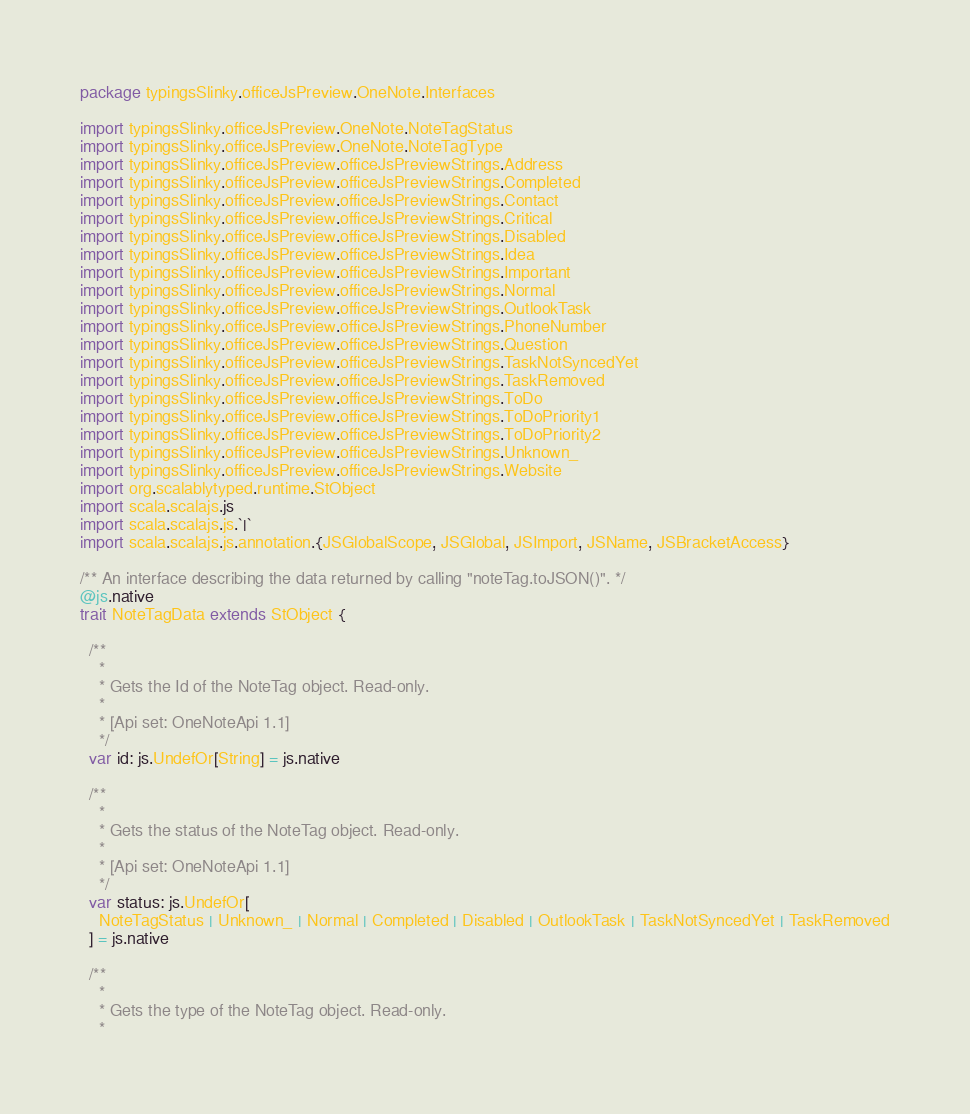<code> <loc_0><loc_0><loc_500><loc_500><_Scala_>package typingsSlinky.officeJsPreview.OneNote.Interfaces

import typingsSlinky.officeJsPreview.OneNote.NoteTagStatus
import typingsSlinky.officeJsPreview.OneNote.NoteTagType
import typingsSlinky.officeJsPreview.officeJsPreviewStrings.Address
import typingsSlinky.officeJsPreview.officeJsPreviewStrings.Completed
import typingsSlinky.officeJsPreview.officeJsPreviewStrings.Contact
import typingsSlinky.officeJsPreview.officeJsPreviewStrings.Critical
import typingsSlinky.officeJsPreview.officeJsPreviewStrings.Disabled
import typingsSlinky.officeJsPreview.officeJsPreviewStrings.Idea
import typingsSlinky.officeJsPreview.officeJsPreviewStrings.Important
import typingsSlinky.officeJsPreview.officeJsPreviewStrings.Normal
import typingsSlinky.officeJsPreview.officeJsPreviewStrings.OutlookTask
import typingsSlinky.officeJsPreview.officeJsPreviewStrings.PhoneNumber
import typingsSlinky.officeJsPreview.officeJsPreviewStrings.Question
import typingsSlinky.officeJsPreview.officeJsPreviewStrings.TaskNotSyncedYet
import typingsSlinky.officeJsPreview.officeJsPreviewStrings.TaskRemoved
import typingsSlinky.officeJsPreview.officeJsPreviewStrings.ToDo
import typingsSlinky.officeJsPreview.officeJsPreviewStrings.ToDoPriority1
import typingsSlinky.officeJsPreview.officeJsPreviewStrings.ToDoPriority2
import typingsSlinky.officeJsPreview.officeJsPreviewStrings.Unknown_
import typingsSlinky.officeJsPreview.officeJsPreviewStrings.Website
import org.scalablytyped.runtime.StObject
import scala.scalajs.js
import scala.scalajs.js.`|`
import scala.scalajs.js.annotation.{JSGlobalScope, JSGlobal, JSImport, JSName, JSBracketAccess}

/** An interface describing the data returned by calling "noteTag.toJSON()". */
@js.native
trait NoteTagData extends StObject {
  
  /**
    *
    * Gets the Id of the NoteTag object. Read-only.
    *
    * [Api set: OneNoteApi 1.1]
    */
  var id: js.UndefOr[String] = js.native
  
  /**
    *
    * Gets the status of the NoteTag object. Read-only.
    *
    * [Api set: OneNoteApi 1.1]
    */
  var status: js.UndefOr[
    NoteTagStatus | Unknown_ | Normal | Completed | Disabled | OutlookTask | TaskNotSyncedYet | TaskRemoved
  ] = js.native
  
  /**
    *
    * Gets the type of the NoteTag object. Read-only.
    *</code> 